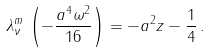Convert formula to latex. <formula><loc_0><loc_0><loc_500><loc_500>\lambda ^ { m } _ { \nu } \, \left ( - \frac { a ^ { 4 } \omega ^ { 2 } } { 1 6 } \right ) = - a ^ { 2 } z - \frac { 1 } { 4 } \, .</formula> 